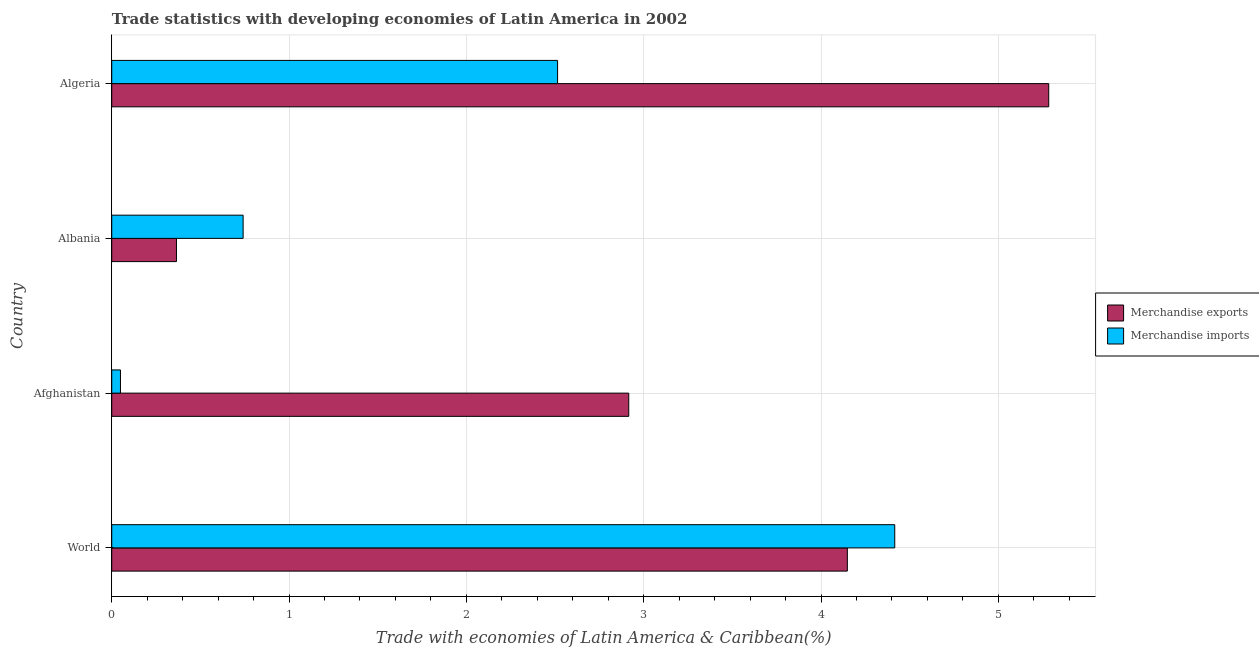How many groups of bars are there?
Your response must be concise. 4. Are the number of bars per tick equal to the number of legend labels?
Offer a terse response. Yes. What is the label of the 1st group of bars from the top?
Your answer should be compact. Algeria. What is the merchandise exports in Afghanistan?
Your answer should be very brief. 2.92. Across all countries, what is the maximum merchandise exports?
Your answer should be very brief. 5.28. Across all countries, what is the minimum merchandise exports?
Provide a short and direct response. 0.37. In which country was the merchandise imports maximum?
Your response must be concise. World. In which country was the merchandise exports minimum?
Provide a succinct answer. Albania. What is the total merchandise exports in the graph?
Give a very brief answer. 12.71. What is the difference between the merchandise imports in Afghanistan and that in World?
Make the answer very short. -4.37. What is the difference between the merchandise exports in World and the merchandise imports in Algeria?
Ensure brevity in your answer.  1.63. What is the average merchandise imports per country?
Your response must be concise. 1.93. What is the difference between the merchandise exports and merchandise imports in World?
Provide a succinct answer. -0.27. In how many countries, is the merchandise exports greater than 2 %?
Ensure brevity in your answer.  3. What is the ratio of the merchandise exports in Albania to that in World?
Make the answer very short. 0.09. Is the merchandise imports in Afghanistan less than that in Albania?
Make the answer very short. Yes. What is the difference between the highest and the second highest merchandise exports?
Your answer should be very brief. 1.14. What is the difference between the highest and the lowest merchandise imports?
Offer a terse response. 4.37. How many bars are there?
Give a very brief answer. 8. Are all the bars in the graph horizontal?
Make the answer very short. Yes. How many countries are there in the graph?
Offer a terse response. 4. What is the difference between two consecutive major ticks on the X-axis?
Your answer should be compact. 1. Are the values on the major ticks of X-axis written in scientific E-notation?
Make the answer very short. No. Does the graph contain grids?
Your response must be concise. Yes. How many legend labels are there?
Your response must be concise. 2. What is the title of the graph?
Keep it short and to the point. Trade statistics with developing economies of Latin America in 2002. What is the label or title of the X-axis?
Make the answer very short. Trade with economies of Latin America & Caribbean(%). What is the label or title of the Y-axis?
Your response must be concise. Country. What is the Trade with economies of Latin America & Caribbean(%) of Merchandise exports in World?
Give a very brief answer. 4.15. What is the Trade with economies of Latin America & Caribbean(%) of Merchandise imports in World?
Ensure brevity in your answer.  4.42. What is the Trade with economies of Latin America & Caribbean(%) in Merchandise exports in Afghanistan?
Offer a very short reply. 2.92. What is the Trade with economies of Latin America & Caribbean(%) in Merchandise imports in Afghanistan?
Ensure brevity in your answer.  0.05. What is the Trade with economies of Latin America & Caribbean(%) of Merchandise exports in Albania?
Provide a short and direct response. 0.37. What is the Trade with economies of Latin America & Caribbean(%) of Merchandise imports in Albania?
Offer a very short reply. 0.74. What is the Trade with economies of Latin America & Caribbean(%) of Merchandise exports in Algeria?
Ensure brevity in your answer.  5.28. What is the Trade with economies of Latin America & Caribbean(%) in Merchandise imports in Algeria?
Provide a succinct answer. 2.51. Across all countries, what is the maximum Trade with economies of Latin America & Caribbean(%) in Merchandise exports?
Make the answer very short. 5.28. Across all countries, what is the maximum Trade with economies of Latin America & Caribbean(%) in Merchandise imports?
Ensure brevity in your answer.  4.42. Across all countries, what is the minimum Trade with economies of Latin America & Caribbean(%) of Merchandise exports?
Provide a short and direct response. 0.37. Across all countries, what is the minimum Trade with economies of Latin America & Caribbean(%) in Merchandise imports?
Your answer should be compact. 0.05. What is the total Trade with economies of Latin America & Caribbean(%) in Merchandise exports in the graph?
Provide a short and direct response. 12.71. What is the total Trade with economies of Latin America & Caribbean(%) of Merchandise imports in the graph?
Offer a terse response. 7.72. What is the difference between the Trade with economies of Latin America & Caribbean(%) of Merchandise exports in World and that in Afghanistan?
Provide a succinct answer. 1.23. What is the difference between the Trade with economies of Latin America & Caribbean(%) in Merchandise imports in World and that in Afghanistan?
Provide a short and direct response. 4.37. What is the difference between the Trade with economies of Latin America & Caribbean(%) in Merchandise exports in World and that in Albania?
Offer a terse response. 3.78. What is the difference between the Trade with economies of Latin America & Caribbean(%) in Merchandise imports in World and that in Albania?
Ensure brevity in your answer.  3.67. What is the difference between the Trade with economies of Latin America & Caribbean(%) in Merchandise exports in World and that in Algeria?
Make the answer very short. -1.14. What is the difference between the Trade with economies of Latin America & Caribbean(%) of Merchandise imports in World and that in Algeria?
Provide a short and direct response. 1.9. What is the difference between the Trade with economies of Latin America & Caribbean(%) of Merchandise exports in Afghanistan and that in Albania?
Your response must be concise. 2.55. What is the difference between the Trade with economies of Latin America & Caribbean(%) of Merchandise imports in Afghanistan and that in Albania?
Ensure brevity in your answer.  -0.69. What is the difference between the Trade with economies of Latin America & Caribbean(%) of Merchandise exports in Afghanistan and that in Algeria?
Your answer should be very brief. -2.37. What is the difference between the Trade with economies of Latin America & Caribbean(%) of Merchandise imports in Afghanistan and that in Algeria?
Your answer should be compact. -2.47. What is the difference between the Trade with economies of Latin America & Caribbean(%) in Merchandise exports in Albania and that in Algeria?
Provide a short and direct response. -4.92. What is the difference between the Trade with economies of Latin America & Caribbean(%) of Merchandise imports in Albania and that in Algeria?
Make the answer very short. -1.77. What is the difference between the Trade with economies of Latin America & Caribbean(%) in Merchandise exports in World and the Trade with economies of Latin America & Caribbean(%) in Merchandise imports in Afghanistan?
Provide a succinct answer. 4.1. What is the difference between the Trade with economies of Latin America & Caribbean(%) of Merchandise exports in World and the Trade with economies of Latin America & Caribbean(%) of Merchandise imports in Albania?
Make the answer very short. 3.41. What is the difference between the Trade with economies of Latin America & Caribbean(%) in Merchandise exports in World and the Trade with economies of Latin America & Caribbean(%) in Merchandise imports in Algeria?
Your answer should be compact. 1.63. What is the difference between the Trade with economies of Latin America & Caribbean(%) in Merchandise exports in Afghanistan and the Trade with economies of Latin America & Caribbean(%) in Merchandise imports in Albania?
Offer a terse response. 2.17. What is the difference between the Trade with economies of Latin America & Caribbean(%) of Merchandise exports in Afghanistan and the Trade with economies of Latin America & Caribbean(%) of Merchandise imports in Algeria?
Keep it short and to the point. 0.4. What is the difference between the Trade with economies of Latin America & Caribbean(%) in Merchandise exports in Albania and the Trade with economies of Latin America & Caribbean(%) in Merchandise imports in Algeria?
Keep it short and to the point. -2.15. What is the average Trade with economies of Latin America & Caribbean(%) of Merchandise exports per country?
Ensure brevity in your answer.  3.18. What is the average Trade with economies of Latin America & Caribbean(%) of Merchandise imports per country?
Ensure brevity in your answer.  1.93. What is the difference between the Trade with economies of Latin America & Caribbean(%) in Merchandise exports and Trade with economies of Latin America & Caribbean(%) in Merchandise imports in World?
Offer a very short reply. -0.27. What is the difference between the Trade with economies of Latin America & Caribbean(%) of Merchandise exports and Trade with economies of Latin America & Caribbean(%) of Merchandise imports in Afghanistan?
Provide a short and direct response. 2.87. What is the difference between the Trade with economies of Latin America & Caribbean(%) in Merchandise exports and Trade with economies of Latin America & Caribbean(%) in Merchandise imports in Albania?
Make the answer very short. -0.38. What is the difference between the Trade with economies of Latin America & Caribbean(%) in Merchandise exports and Trade with economies of Latin America & Caribbean(%) in Merchandise imports in Algeria?
Your answer should be compact. 2.77. What is the ratio of the Trade with economies of Latin America & Caribbean(%) in Merchandise exports in World to that in Afghanistan?
Ensure brevity in your answer.  1.42. What is the ratio of the Trade with economies of Latin America & Caribbean(%) of Merchandise imports in World to that in Afghanistan?
Keep it short and to the point. 89.81. What is the ratio of the Trade with economies of Latin America & Caribbean(%) of Merchandise exports in World to that in Albania?
Your answer should be very brief. 11.36. What is the ratio of the Trade with economies of Latin America & Caribbean(%) of Merchandise imports in World to that in Albania?
Keep it short and to the point. 5.96. What is the ratio of the Trade with economies of Latin America & Caribbean(%) of Merchandise exports in World to that in Algeria?
Provide a succinct answer. 0.79. What is the ratio of the Trade with economies of Latin America & Caribbean(%) in Merchandise imports in World to that in Algeria?
Provide a succinct answer. 1.76. What is the ratio of the Trade with economies of Latin America & Caribbean(%) in Merchandise exports in Afghanistan to that in Albania?
Give a very brief answer. 7.99. What is the ratio of the Trade with economies of Latin America & Caribbean(%) of Merchandise imports in Afghanistan to that in Albania?
Provide a short and direct response. 0.07. What is the ratio of the Trade with economies of Latin America & Caribbean(%) of Merchandise exports in Afghanistan to that in Algeria?
Give a very brief answer. 0.55. What is the ratio of the Trade with economies of Latin America & Caribbean(%) in Merchandise imports in Afghanistan to that in Algeria?
Give a very brief answer. 0.02. What is the ratio of the Trade with economies of Latin America & Caribbean(%) of Merchandise exports in Albania to that in Algeria?
Give a very brief answer. 0.07. What is the ratio of the Trade with economies of Latin America & Caribbean(%) in Merchandise imports in Albania to that in Algeria?
Give a very brief answer. 0.29. What is the difference between the highest and the second highest Trade with economies of Latin America & Caribbean(%) in Merchandise exports?
Offer a very short reply. 1.14. What is the difference between the highest and the second highest Trade with economies of Latin America & Caribbean(%) in Merchandise imports?
Ensure brevity in your answer.  1.9. What is the difference between the highest and the lowest Trade with economies of Latin America & Caribbean(%) of Merchandise exports?
Make the answer very short. 4.92. What is the difference between the highest and the lowest Trade with economies of Latin America & Caribbean(%) of Merchandise imports?
Provide a succinct answer. 4.37. 